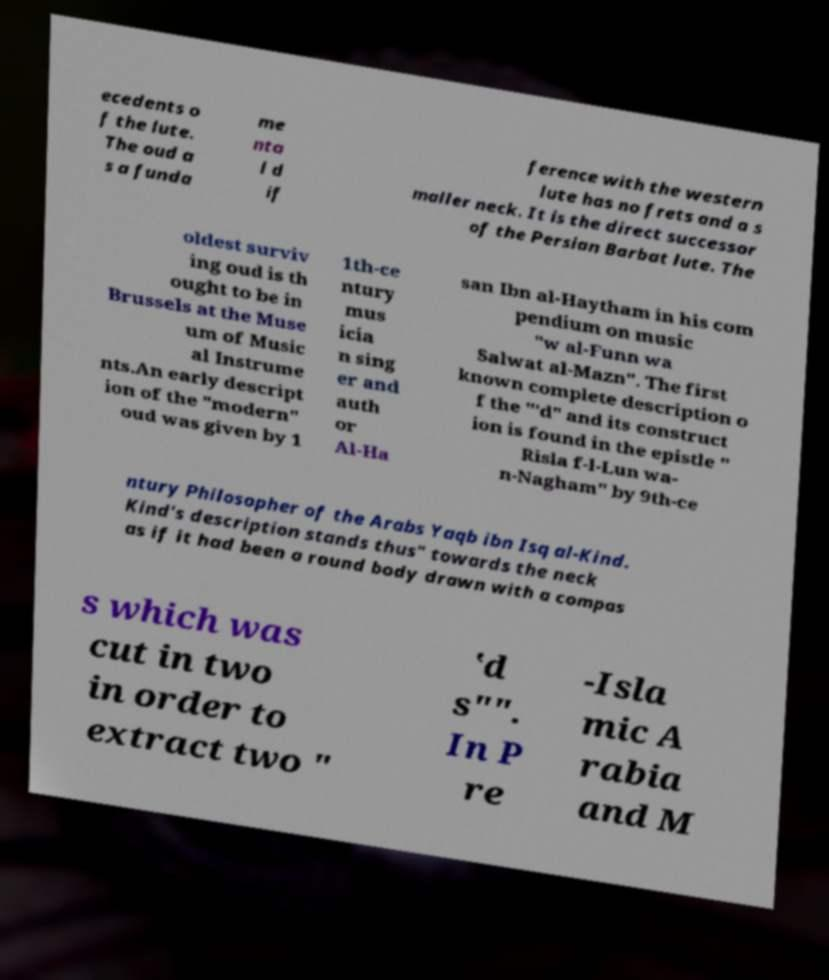I need the written content from this picture converted into text. Can you do that? ecedents o f the lute. The oud a s a funda me nta l d if ference with the western lute has no frets and a s maller neck. It is the direct successor of the Persian Barbat lute. The oldest surviv ing oud is th ought to be in Brussels at the Muse um of Music al Instrume nts.An early descript ion of the "modern" oud was given by 1 1th-ce ntury mus icia n sing er and auth or Al-Ha san Ibn al-Haytham in his com pendium on music "w al-Funn wa Salwat al-Mazn". The first known complete description o f the "‛d" and its construct ion is found in the epistle " Risla f-l-Lun wa- n-Nagham" by 9th-ce ntury Philosopher of the Arabs Yaqb ibn Isq al-Kind. Kind's description stands thus" towards the neck as if it had been a round body drawn with a compas s which was cut in two in order to extract two " ‛d s"". In P re -Isla mic A rabia and M 